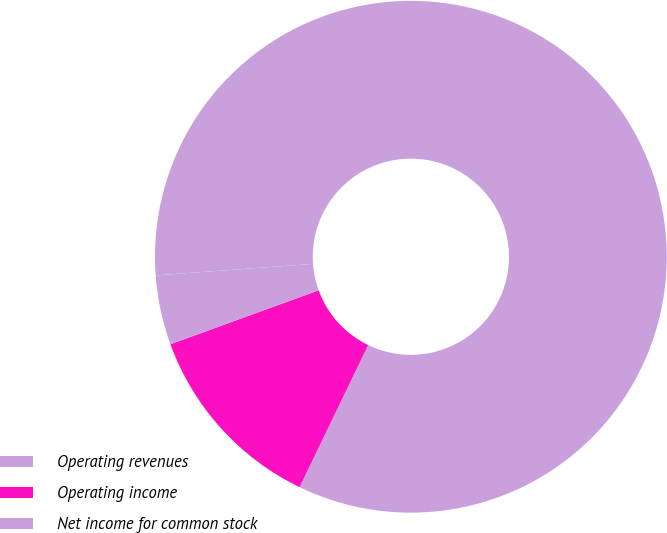Convert chart. <chart><loc_0><loc_0><loc_500><loc_500><pie_chart><fcel>Operating revenues<fcel>Operating income<fcel>Net income for common stock<nl><fcel>83.32%<fcel>12.29%<fcel>4.39%<nl></chart> 